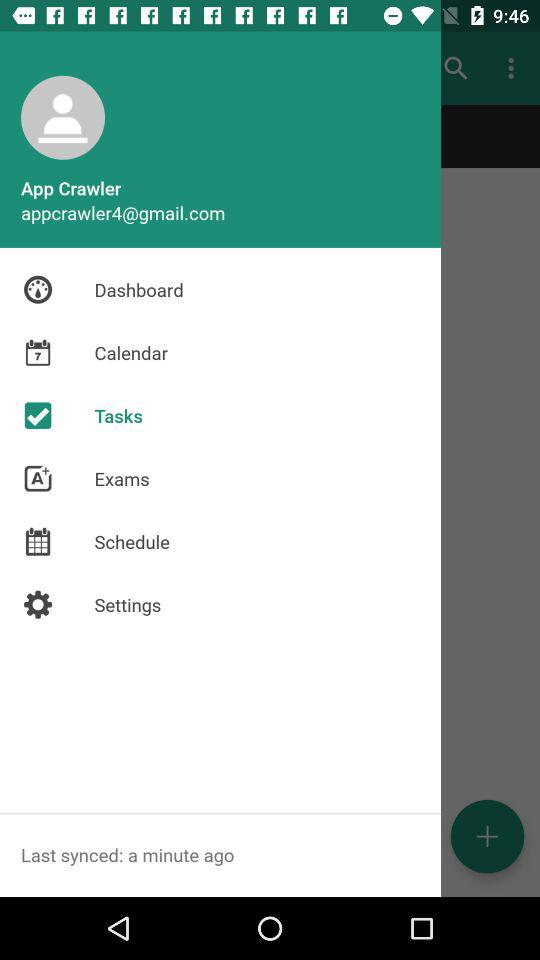What is the email address? The email address is appcrawler4@gmail.com. 